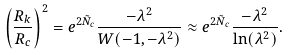Convert formula to latex. <formula><loc_0><loc_0><loc_500><loc_500>\left ( \frac { R _ { k } } { R _ { c } } \right ) ^ { 2 } = e ^ { 2 \tilde { N } _ { c } } \frac { - \lambda ^ { 2 } } { W ( - 1 , - \lambda ^ { 2 } ) } \approx e ^ { 2 \tilde { N } _ { c } } \frac { - \lambda ^ { 2 } } { \ln ( \lambda ^ { 2 } ) } .</formula> 